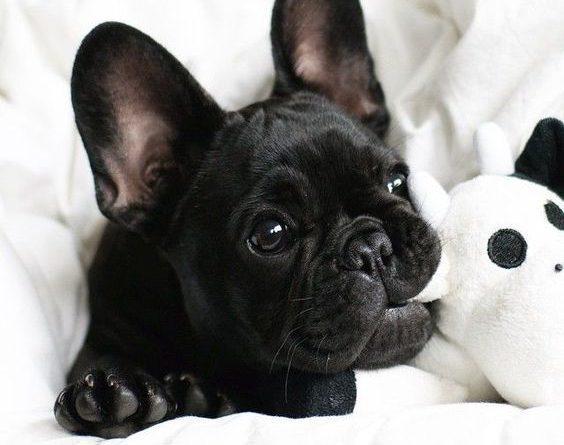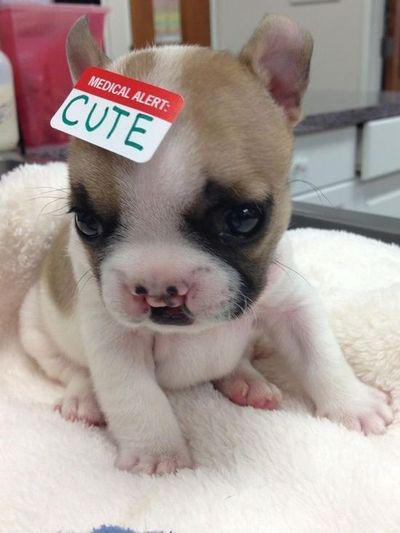The first image is the image on the left, the second image is the image on the right. Evaluate the accuracy of this statement regarding the images: "The image on the left contains no more than one dog with its ears perked up.". Is it true? Answer yes or no. Yes. The first image is the image on the left, the second image is the image on the right. Evaluate the accuracy of this statement regarding the images: "There are at most two dogs.". Is it true? Answer yes or no. Yes. 